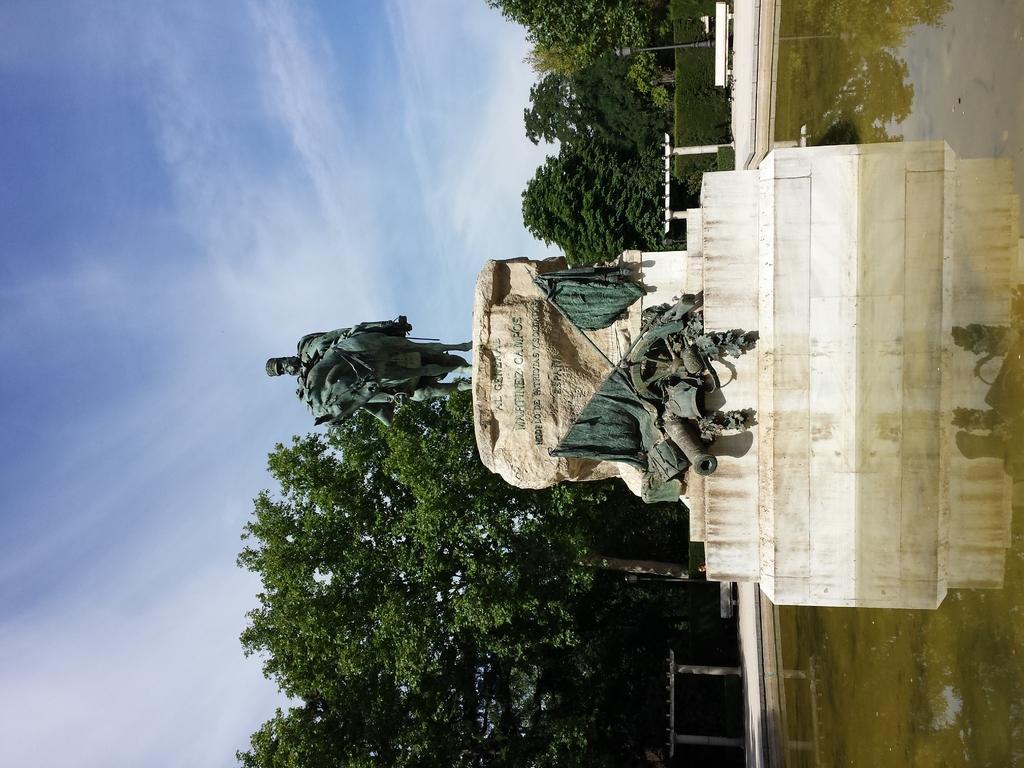Could you give a brief overview of what you see in this image? In this mage in the center of there is one statue and a wall, on the wall there is some text and in the background there are some trees and railing. On the right side there is a fountain and on the left side there is sky. 